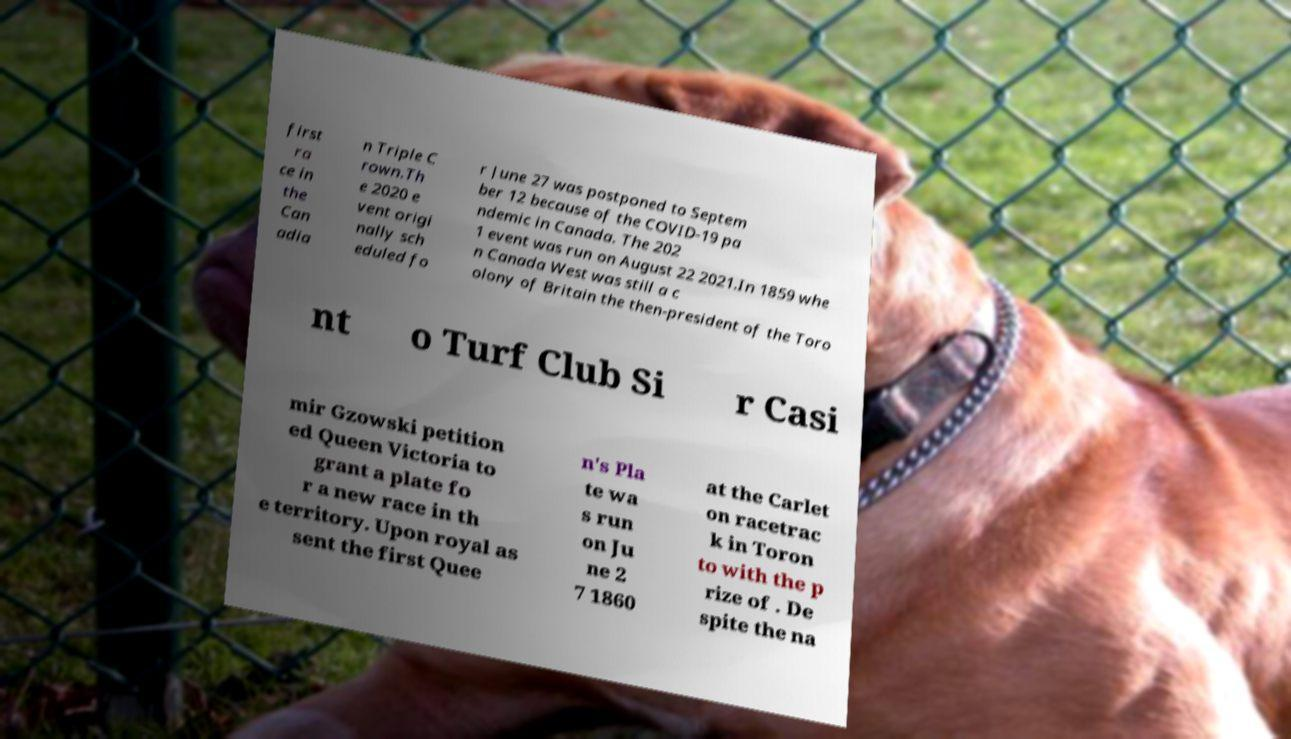Could you extract and type out the text from this image? first ra ce in the Can adia n Triple C rown.Th e 2020 e vent origi nally sch eduled fo r June 27 was postponed to Septem ber 12 because of the COVID-19 pa ndemic in Canada. The 202 1 event was run on August 22 2021.In 1859 whe n Canada West was still a c olony of Britain the then-president of the Toro nt o Turf Club Si r Casi mir Gzowski petition ed Queen Victoria to grant a plate fo r a new race in th e territory. Upon royal as sent the first Quee n's Pla te wa s run on Ju ne 2 7 1860 at the Carlet on racetrac k in Toron to with the p rize of . De spite the na 